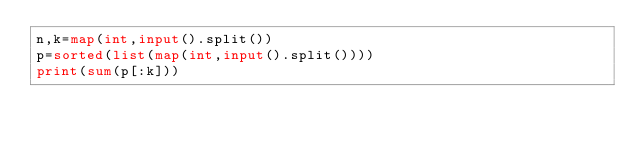Convert code to text. <code><loc_0><loc_0><loc_500><loc_500><_Python_>n,k=map(int,input().split())
p=sorted(list(map(int,input().split())))
print(sum(p[:k]))</code> 